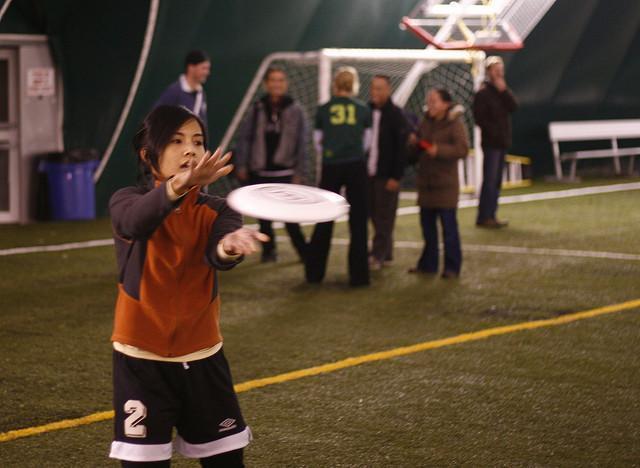How many people are there?
Give a very brief answer. 7. 